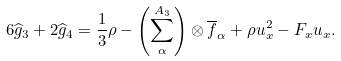<formula> <loc_0><loc_0><loc_500><loc_500>6 \widehat { g } _ { 3 } + 2 \widehat { g } _ { 4 } = \frac { 1 } { 3 } \rho - \left ( \sum _ { \alpha } ^ { A _ { 3 } } \right ) \otimes \overline { f } _ { \alpha } + \rho u _ { x } ^ { 2 } - F _ { x } u _ { x } .</formula> 